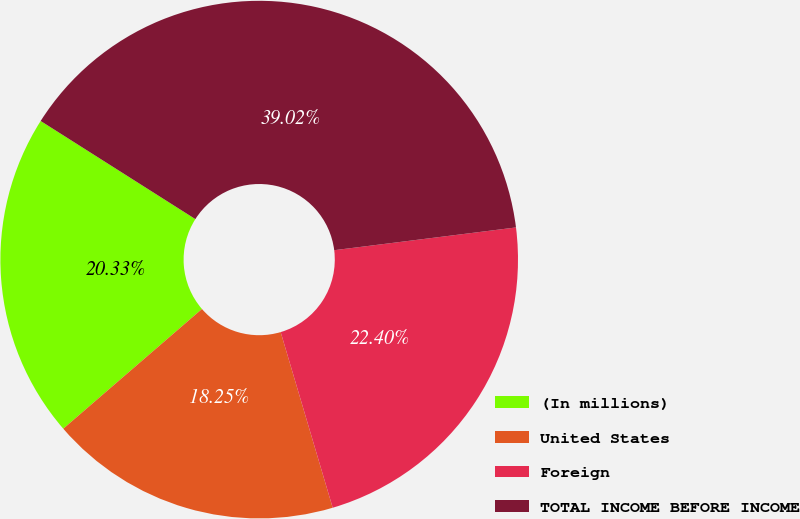Convert chart. <chart><loc_0><loc_0><loc_500><loc_500><pie_chart><fcel>(In millions)<fcel>United States<fcel>Foreign<fcel>TOTAL INCOME BEFORE INCOME<nl><fcel>20.33%<fcel>18.25%<fcel>22.4%<fcel>39.02%<nl></chart> 